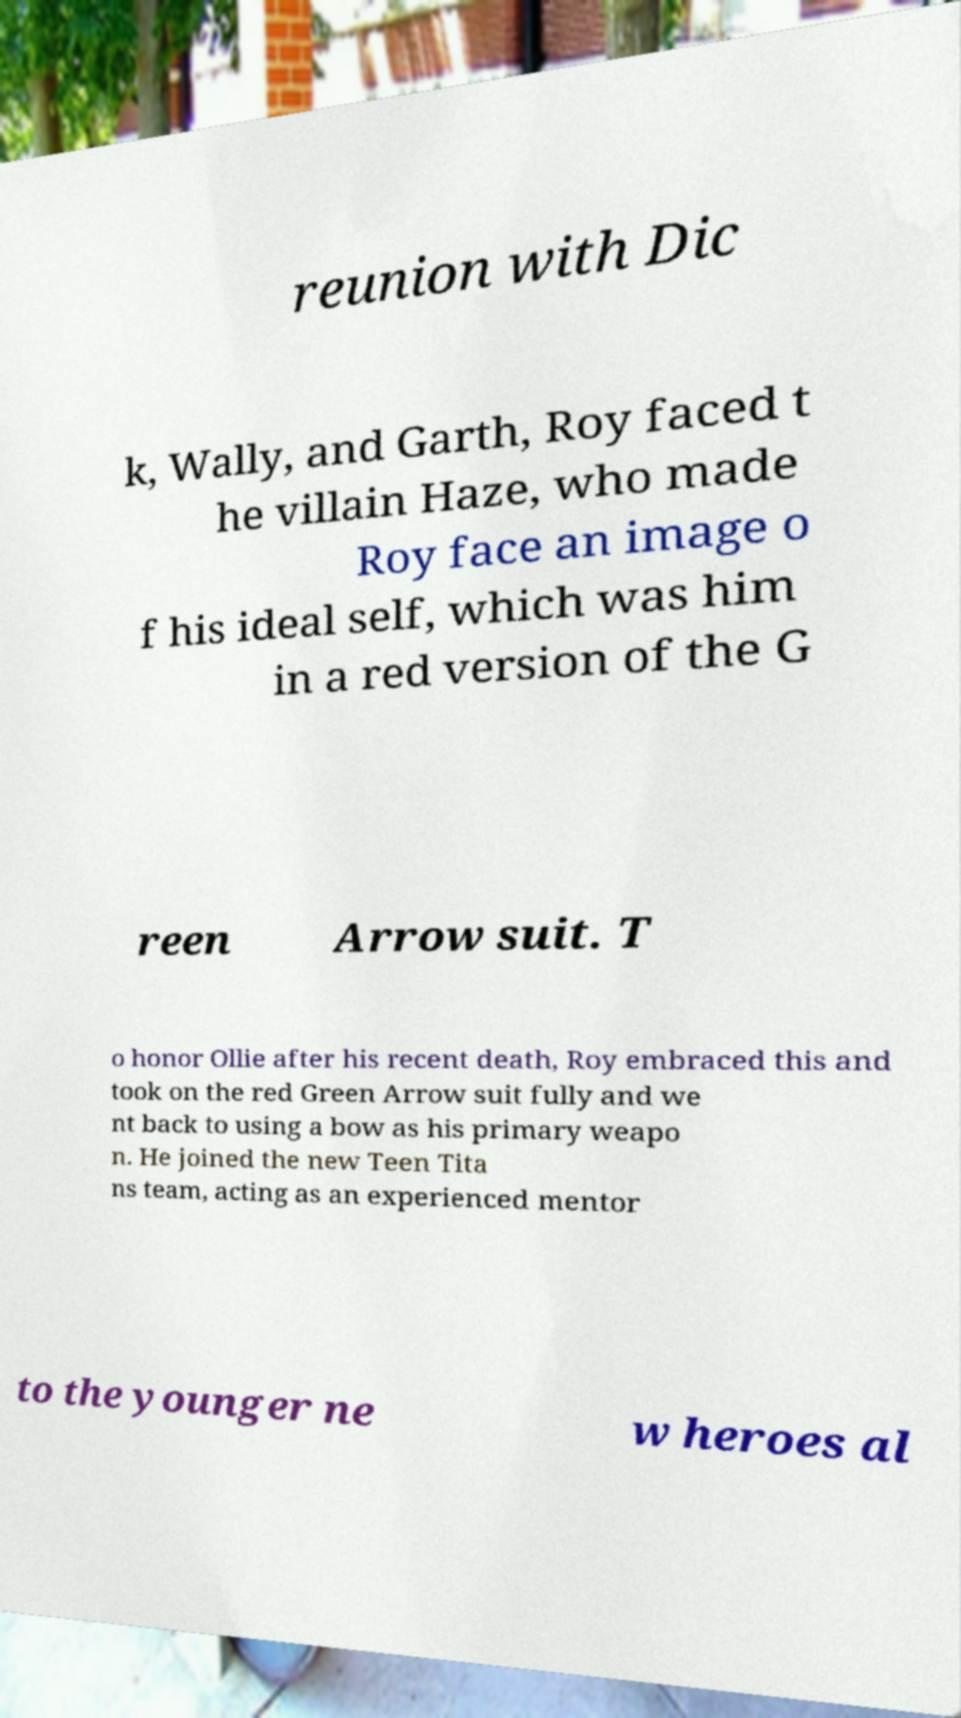For documentation purposes, I need the text within this image transcribed. Could you provide that? reunion with Dic k, Wally, and Garth, Roy faced t he villain Haze, who made Roy face an image o f his ideal self, which was him in a red version of the G reen Arrow suit. T o honor Ollie after his recent death, Roy embraced this and took on the red Green Arrow suit fully and we nt back to using a bow as his primary weapo n. He joined the new Teen Tita ns team, acting as an experienced mentor to the younger ne w heroes al 